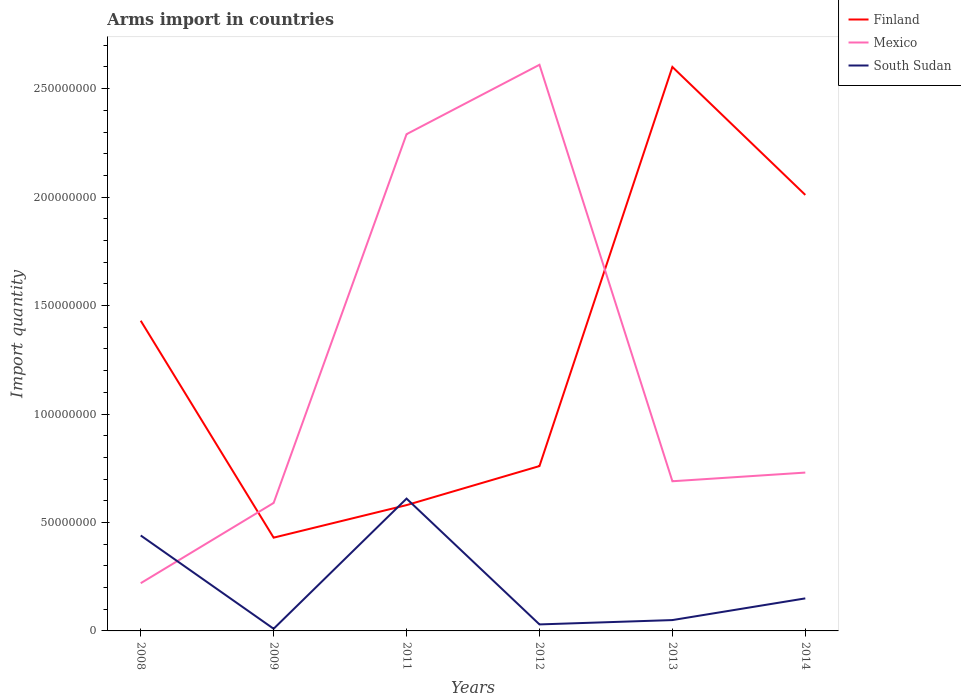Across all years, what is the maximum total arms import in South Sudan?
Your answer should be very brief. 1.00e+06. In which year was the total arms import in Mexico maximum?
Your answer should be compact. 2008. What is the total total arms import in South Sudan in the graph?
Give a very brief answer. -1.70e+07. What is the difference between the highest and the second highest total arms import in Mexico?
Provide a succinct answer. 2.39e+08. What is the difference between the highest and the lowest total arms import in Mexico?
Your answer should be very brief. 2. What is the difference between two consecutive major ticks on the Y-axis?
Ensure brevity in your answer.  5.00e+07. Are the values on the major ticks of Y-axis written in scientific E-notation?
Keep it short and to the point. No. Does the graph contain any zero values?
Give a very brief answer. No. Does the graph contain grids?
Give a very brief answer. No. What is the title of the graph?
Provide a succinct answer. Arms import in countries. Does "Latvia" appear as one of the legend labels in the graph?
Offer a terse response. No. What is the label or title of the X-axis?
Provide a short and direct response. Years. What is the label or title of the Y-axis?
Your answer should be very brief. Import quantity. What is the Import quantity of Finland in 2008?
Ensure brevity in your answer.  1.43e+08. What is the Import quantity of Mexico in 2008?
Ensure brevity in your answer.  2.20e+07. What is the Import quantity in South Sudan in 2008?
Your answer should be very brief. 4.40e+07. What is the Import quantity of Finland in 2009?
Ensure brevity in your answer.  4.30e+07. What is the Import quantity in Mexico in 2009?
Your answer should be very brief. 5.90e+07. What is the Import quantity in Finland in 2011?
Your answer should be compact. 5.80e+07. What is the Import quantity of Mexico in 2011?
Ensure brevity in your answer.  2.29e+08. What is the Import quantity of South Sudan in 2011?
Provide a succinct answer. 6.10e+07. What is the Import quantity in Finland in 2012?
Your answer should be compact. 7.60e+07. What is the Import quantity in Mexico in 2012?
Give a very brief answer. 2.61e+08. What is the Import quantity of Finland in 2013?
Your answer should be very brief. 2.60e+08. What is the Import quantity of Mexico in 2013?
Provide a succinct answer. 6.90e+07. What is the Import quantity of South Sudan in 2013?
Offer a terse response. 5.00e+06. What is the Import quantity in Finland in 2014?
Offer a terse response. 2.01e+08. What is the Import quantity of Mexico in 2014?
Provide a succinct answer. 7.30e+07. What is the Import quantity of South Sudan in 2014?
Provide a short and direct response. 1.50e+07. Across all years, what is the maximum Import quantity in Finland?
Offer a very short reply. 2.60e+08. Across all years, what is the maximum Import quantity of Mexico?
Make the answer very short. 2.61e+08. Across all years, what is the maximum Import quantity of South Sudan?
Your response must be concise. 6.10e+07. Across all years, what is the minimum Import quantity of Finland?
Offer a terse response. 4.30e+07. Across all years, what is the minimum Import quantity of Mexico?
Make the answer very short. 2.20e+07. What is the total Import quantity of Finland in the graph?
Your response must be concise. 7.81e+08. What is the total Import quantity in Mexico in the graph?
Make the answer very short. 7.13e+08. What is the total Import quantity of South Sudan in the graph?
Your response must be concise. 1.29e+08. What is the difference between the Import quantity of Mexico in 2008 and that in 2009?
Provide a short and direct response. -3.70e+07. What is the difference between the Import quantity in South Sudan in 2008 and that in 2009?
Your answer should be very brief. 4.30e+07. What is the difference between the Import quantity in Finland in 2008 and that in 2011?
Offer a terse response. 8.50e+07. What is the difference between the Import quantity of Mexico in 2008 and that in 2011?
Keep it short and to the point. -2.07e+08. What is the difference between the Import quantity of South Sudan in 2008 and that in 2011?
Provide a short and direct response. -1.70e+07. What is the difference between the Import quantity of Finland in 2008 and that in 2012?
Your answer should be very brief. 6.70e+07. What is the difference between the Import quantity of Mexico in 2008 and that in 2012?
Give a very brief answer. -2.39e+08. What is the difference between the Import quantity of South Sudan in 2008 and that in 2012?
Your response must be concise. 4.10e+07. What is the difference between the Import quantity of Finland in 2008 and that in 2013?
Provide a short and direct response. -1.17e+08. What is the difference between the Import quantity in Mexico in 2008 and that in 2013?
Your answer should be very brief. -4.70e+07. What is the difference between the Import quantity in South Sudan in 2008 and that in 2013?
Offer a terse response. 3.90e+07. What is the difference between the Import quantity in Finland in 2008 and that in 2014?
Provide a succinct answer. -5.80e+07. What is the difference between the Import quantity in Mexico in 2008 and that in 2014?
Give a very brief answer. -5.10e+07. What is the difference between the Import quantity of South Sudan in 2008 and that in 2014?
Your answer should be very brief. 2.90e+07. What is the difference between the Import quantity in Finland in 2009 and that in 2011?
Your answer should be very brief. -1.50e+07. What is the difference between the Import quantity of Mexico in 2009 and that in 2011?
Provide a short and direct response. -1.70e+08. What is the difference between the Import quantity of South Sudan in 2009 and that in 2011?
Offer a terse response. -6.00e+07. What is the difference between the Import quantity of Finland in 2009 and that in 2012?
Keep it short and to the point. -3.30e+07. What is the difference between the Import quantity of Mexico in 2009 and that in 2012?
Provide a short and direct response. -2.02e+08. What is the difference between the Import quantity of Finland in 2009 and that in 2013?
Your answer should be very brief. -2.17e+08. What is the difference between the Import quantity of Mexico in 2009 and that in 2013?
Your answer should be very brief. -1.00e+07. What is the difference between the Import quantity of Finland in 2009 and that in 2014?
Provide a succinct answer. -1.58e+08. What is the difference between the Import quantity in Mexico in 2009 and that in 2014?
Ensure brevity in your answer.  -1.40e+07. What is the difference between the Import quantity in South Sudan in 2009 and that in 2014?
Ensure brevity in your answer.  -1.40e+07. What is the difference between the Import quantity in Finland in 2011 and that in 2012?
Your response must be concise. -1.80e+07. What is the difference between the Import quantity of Mexico in 2011 and that in 2012?
Give a very brief answer. -3.20e+07. What is the difference between the Import quantity of South Sudan in 2011 and that in 2012?
Make the answer very short. 5.80e+07. What is the difference between the Import quantity in Finland in 2011 and that in 2013?
Your answer should be very brief. -2.02e+08. What is the difference between the Import quantity of Mexico in 2011 and that in 2013?
Give a very brief answer. 1.60e+08. What is the difference between the Import quantity in South Sudan in 2011 and that in 2013?
Your response must be concise. 5.60e+07. What is the difference between the Import quantity of Finland in 2011 and that in 2014?
Your response must be concise. -1.43e+08. What is the difference between the Import quantity in Mexico in 2011 and that in 2014?
Provide a short and direct response. 1.56e+08. What is the difference between the Import quantity in South Sudan in 2011 and that in 2014?
Your response must be concise. 4.60e+07. What is the difference between the Import quantity in Finland in 2012 and that in 2013?
Give a very brief answer. -1.84e+08. What is the difference between the Import quantity in Mexico in 2012 and that in 2013?
Provide a succinct answer. 1.92e+08. What is the difference between the Import quantity in Finland in 2012 and that in 2014?
Give a very brief answer. -1.25e+08. What is the difference between the Import quantity of Mexico in 2012 and that in 2014?
Offer a very short reply. 1.88e+08. What is the difference between the Import quantity in South Sudan in 2012 and that in 2014?
Ensure brevity in your answer.  -1.20e+07. What is the difference between the Import quantity in Finland in 2013 and that in 2014?
Keep it short and to the point. 5.90e+07. What is the difference between the Import quantity of Mexico in 2013 and that in 2014?
Keep it short and to the point. -4.00e+06. What is the difference between the Import quantity in South Sudan in 2013 and that in 2014?
Provide a short and direct response. -1.00e+07. What is the difference between the Import quantity in Finland in 2008 and the Import quantity in Mexico in 2009?
Your response must be concise. 8.40e+07. What is the difference between the Import quantity of Finland in 2008 and the Import quantity of South Sudan in 2009?
Provide a succinct answer. 1.42e+08. What is the difference between the Import quantity in Mexico in 2008 and the Import quantity in South Sudan in 2009?
Your response must be concise. 2.10e+07. What is the difference between the Import quantity of Finland in 2008 and the Import quantity of Mexico in 2011?
Ensure brevity in your answer.  -8.60e+07. What is the difference between the Import quantity in Finland in 2008 and the Import quantity in South Sudan in 2011?
Offer a terse response. 8.20e+07. What is the difference between the Import quantity in Mexico in 2008 and the Import quantity in South Sudan in 2011?
Keep it short and to the point. -3.90e+07. What is the difference between the Import quantity in Finland in 2008 and the Import quantity in Mexico in 2012?
Give a very brief answer. -1.18e+08. What is the difference between the Import quantity of Finland in 2008 and the Import quantity of South Sudan in 2012?
Give a very brief answer. 1.40e+08. What is the difference between the Import quantity in Mexico in 2008 and the Import quantity in South Sudan in 2012?
Your answer should be compact. 1.90e+07. What is the difference between the Import quantity of Finland in 2008 and the Import quantity of Mexico in 2013?
Offer a terse response. 7.40e+07. What is the difference between the Import quantity in Finland in 2008 and the Import quantity in South Sudan in 2013?
Keep it short and to the point. 1.38e+08. What is the difference between the Import quantity in Mexico in 2008 and the Import quantity in South Sudan in 2013?
Ensure brevity in your answer.  1.70e+07. What is the difference between the Import quantity of Finland in 2008 and the Import quantity of Mexico in 2014?
Provide a succinct answer. 7.00e+07. What is the difference between the Import quantity in Finland in 2008 and the Import quantity in South Sudan in 2014?
Provide a short and direct response. 1.28e+08. What is the difference between the Import quantity in Mexico in 2008 and the Import quantity in South Sudan in 2014?
Your answer should be compact. 7.00e+06. What is the difference between the Import quantity of Finland in 2009 and the Import quantity of Mexico in 2011?
Provide a succinct answer. -1.86e+08. What is the difference between the Import quantity in Finland in 2009 and the Import quantity in South Sudan in 2011?
Give a very brief answer. -1.80e+07. What is the difference between the Import quantity of Mexico in 2009 and the Import quantity of South Sudan in 2011?
Your answer should be compact. -2.00e+06. What is the difference between the Import quantity of Finland in 2009 and the Import quantity of Mexico in 2012?
Offer a very short reply. -2.18e+08. What is the difference between the Import quantity in Finland in 2009 and the Import quantity in South Sudan in 2012?
Make the answer very short. 4.00e+07. What is the difference between the Import quantity in Mexico in 2009 and the Import quantity in South Sudan in 2012?
Your answer should be compact. 5.60e+07. What is the difference between the Import quantity of Finland in 2009 and the Import quantity of Mexico in 2013?
Your answer should be very brief. -2.60e+07. What is the difference between the Import quantity in Finland in 2009 and the Import quantity in South Sudan in 2013?
Your answer should be compact. 3.80e+07. What is the difference between the Import quantity in Mexico in 2009 and the Import quantity in South Sudan in 2013?
Offer a terse response. 5.40e+07. What is the difference between the Import quantity in Finland in 2009 and the Import quantity in Mexico in 2014?
Provide a short and direct response. -3.00e+07. What is the difference between the Import quantity in Finland in 2009 and the Import quantity in South Sudan in 2014?
Provide a short and direct response. 2.80e+07. What is the difference between the Import quantity of Mexico in 2009 and the Import quantity of South Sudan in 2014?
Your answer should be very brief. 4.40e+07. What is the difference between the Import quantity of Finland in 2011 and the Import quantity of Mexico in 2012?
Give a very brief answer. -2.03e+08. What is the difference between the Import quantity of Finland in 2011 and the Import quantity of South Sudan in 2012?
Provide a succinct answer. 5.50e+07. What is the difference between the Import quantity in Mexico in 2011 and the Import quantity in South Sudan in 2012?
Provide a short and direct response. 2.26e+08. What is the difference between the Import quantity of Finland in 2011 and the Import quantity of Mexico in 2013?
Your answer should be compact. -1.10e+07. What is the difference between the Import quantity of Finland in 2011 and the Import quantity of South Sudan in 2013?
Your response must be concise. 5.30e+07. What is the difference between the Import quantity in Mexico in 2011 and the Import quantity in South Sudan in 2013?
Make the answer very short. 2.24e+08. What is the difference between the Import quantity of Finland in 2011 and the Import quantity of Mexico in 2014?
Offer a terse response. -1.50e+07. What is the difference between the Import quantity of Finland in 2011 and the Import quantity of South Sudan in 2014?
Your response must be concise. 4.30e+07. What is the difference between the Import quantity in Mexico in 2011 and the Import quantity in South Sudan in 2014?
Make the answer very short. 2.14e+08. What is the difference between the Import quantity in Finland in 2012 and the Import quantity in South Sudan in 2013?
Offer a very short reply. 7.10e+07. What is the difference between the Import quantity of Mexico in 2012 and the Import quantity of South Sudan in 2013?
Make the answer very short. 2.56e+08. What is the difference between the Import quantity of Finland in 2012 and the Import quantity of South Sudan in 2014?
Your response must be concise. 6.10e+07. What is the difference between the Import quantity of Mexico in 2012 and the Import quantity of South Sudan in 2014?
Provide a succinct answer. 2.46e+08. What is the difference between the Import quantity in Finland in 2013 and the Import quantity in Mexico in 2014?
Offer a terse response. 1.87e+08. What is the difference between the Import quantity in Finland in 2013 and the Import quantity in South Sudan in 2014?
Your answer should be compact. 2.45e+08. What is the difference between the Import quantity of Mexico in 2013 and the Import quantity of South Sudan in 2014?
Offer a terse response. 5.40e+07. What is the average Import quantity in Finland per year?
Your answer should be compact. 1.30e+08. What is the average Import quantity of Mexico per year?
Ensure brevity in your answer.  1.19e+08. What is the average Import quantity of South Sudan per year?
Offer a terse response. 2.15e+07. In the year 2008, what is the difference between the Import quantity in Finland and Import quantity in Mexico?
Offer a terse response. 1.21e+08. In the year 2008, what is the difference between the Import quantity in Finland and Import quantity in South Sudan?
Provide a succinct answer. 9.90e+07. In the year 2008, what is the difference between the Import quantity of Mexico and Import quantity of South Sudan?
Give a very brief answer. -2.20e+07. In the year 2009, what is the difference between the Import quantity in Finland and Import quantity in Mexico?
Provide a short and direct response. -1.60e+07. In the year 2009, what is the difference between the Import quantity in Finland and Import quantity in South Sudan?
Give a very brief answer. 4.20e+07. In the year 2009, what is the difference between the Import quantity of Mexico and Import quantity of South Sudan?
Your answer should be very brief. 5.80e+07. In the year 2011, what is the difference between the Import quantity of Finland and Import quantity of Mexico?
Provide a succinct answer. -1.71e+08. In the year 2011, what is the difference between the Import quantity of Mexico and Import quantity of South Sudan?
Give a very brief answer. 1.68e+08. In the year 2012, what is the difference between the Import quantity of Finland and Import quantity of Mexico?
Give a very brief answer. -1.85e+08. In the year 2012, what is the difference between the Import quantity of Finland and Import quantity of South Sudan?
Your answer should be very brief. 7.30e+07. In the year 2012, what is the difference between the Import quantity in Mexico and Import quantity in South Sudan?
Your answer should be very brief. 2.58e+08. In the year 2013, what is the difference between the Import quantity in Finland and Import quantity in Mexico?
Your response must be concise. 1.91e+08. In the year 2013, what is the difference between the Import quantity of Finland and Import quantity of South Sudan?
Provide a short and direct response. 2.55e+08. In the year 2013, what is the difference between the Import quantity of Mexico and Import quantity of South Sudan?
Offer a very short reply. 6.40e+07. In the year 2014, what is the difference between the Import quantity in Finland and Import quantity in Mexico?
Provide a short and direct response. 1.28e+08. In the year 2014, what is the difference between the Import quantity of Finland and Import quantity of South Sudan?
Give a very brief answer. 1.86e+08. In the year 2014, what is the difference between the Import quantity of Mexico and Import quantity of South Sudan?
Offer a very short reply. 5.80e+07. What is the ratio of the Import quantity in Finland in 2008 to that in 2009?
Your answer should be very brief. 3.33. What is the ratio of the Import quantity in Mexico in 2008 to that in 2009?
Offer a very short reply. 0.37. What is the ratio of the Import quantity of South Sudan in 2008 to that in 2009?
Make the answer very short. 44. What is the ratio of the Import quantity of Finland in 2008 to that in 2011?
Make the answer very short. 2.47. What is the ratio of the Import quantity of Mexico in 2008 to that in 2011?
Keep it short and to the point. 0.1. What is the ratio of the Import quantity in South Sudan in 2008 to that in 2011?
Your answer should be compact. 0.72. What is the ratio of the Import quantity in Finland in 2008 to that in 2012?
Provide a succinct answer. 1.88. What is the ratio of the Import quantity in Mexico in 2008 to that in 2012?
Provide a short and direct response. 0.08. What is the ratio of the Import quantity of South Sudan in 2008 to that in 2012?
Provide a succinct answer. 14.67. What is the ratio of the Import quantity of Finland in 2008 to that in 2013?
Your answer should be compact. 0.55. What is the ratio of the Import quantity in Mexico in 2008 to that in 2013?
Give a very brief answer. 0.32. What is the ratio of the Import quantity in South Sudan in 2008 to that in 2013?
Your response must be concise. 8.8. What is the ratio of the Import quantity in Finland in 2008 to that in 2014?
Make the answer very short. 0.71. What is the ratio of the Import quantity in Mexico in 2008 to that in 2014?
Offer a very short reply. 0.3. What is the ratio of the Import quantity in South Sudan in 2008 to that in 2014?
Give a very brief answer. 2.93. What is the ratio of the Import quantity in Finland in 2009 to that in 2011?
Give a very brief answer. 0.74. What is the ratio of the Import quantity of Mexico in 2009 to that in 2011?
Make the answer very short. 0.26. What is the ratio of the Import quantity in South Sudan in 2009 to that in 2011?
Your response must be concise. 0.02. What is the ratio of the Import quantity of Finland in 2009 to that in 2012?
Make the answer very short. 0.57. What is the ratio of the Import quantity of Mexico in 2009 to that in 2012?
Offer a very short reply. 0.23. What is the ratio of the Import quantity of South Sudan in 2009 to that in 2012?
Your answer should be very brief. 0.33. What is the ratio of the Import quantity in Finland in 2009 to that in 2013?
Your answer should be compact. 0.17. What is the ratio of the Import quantity in Mexico in 2009 to that in 2013?
Your answer should be compact. 0.86. What is the ratio of the Import quantity of Finland in 2009 to that in 2014?
Provide a short and direct response. 0.21. What is the ratio of the Import quantity of Mexico in 2009 to that in 2014?
Your answer should be very brief. 0.81. What is the ratio of the Import quantity of South Sudan in 2009 to that in 2014?
Keep it short and to the point. 0.07. What is the ratio of the Import quantity in Finland in 2011 to that in 2012?
Your answer should be very brief. 0.76. What is the ratio of the Import quantity of Mexico in 2011 to that in 2012?
Ensure brevity in your answer.  0.88. What is the ratio of the Import quantity in South Sudan in 2011 to that in 2012?
Give a very brief answer. 20.33. What is the ratio of the Import quantity of Finland in 2011 to that in 2013?
Your answer should be compact. 0.22. What is the ratio of the Import quantity of Mexico in 2011 to that in 2013?
Your answer should be compact. 3.32. What is the ratio of the Import quantity in South Sudan in 2011 to that in 2013?
Keep it short and to the point. 12.2. What is the ratio of the Import quantity in Finland in 2011 to that in 2014?
Keep it short and to the point. 0.29. What is the ratio of the Import quantity in Mexico in 2011 to that in 2014?
Provide a short and direct response. 3.14. What is the ratio of the Import quantity in South Sudan in 2011 to that in 2014?
Your answer should be compact. 4.07. What is the ratio of the Import quantity of Finland in 2012 to that in 2013?
Offer a very short reply. 0.29. What is the ratio of the Import quantity of Mexico in 2012 to that in 2013?
Offer a very short reply. 3.78. What is the ratio of the Import quantity of South Sudan in 2012 to that in 2013?
Provide a succinct answer. 0.6. What is the ratio of the Import quantity in Finland in 2012 to that in 2014?
Your answer should be compact. 0.38. What is the ratio of the Import quantity in Mexico in 2012 to that in 2014?
Keep it short and to the point. 3.58. What is the ratio of the Import quantity of Finland in 2013 to that in 2014?
Your answer should be compact. 1.29. What is the ratio of the Import quantity of Mexico in 2013 to that in 2014?
Make the answer very short. 0.95. What is the difference between the highest and the second highest Import quantity of Finland?
Give a very brief answer. 5.90e+07. What is the difference between the highest and the second highest Import quantity of Mexico?
Ensure brevity in your answer.  3.20e+07. What is the difference between the highest and the second highest Import quantity of South Sudan?
Offer a terse response. 1.70e+07. What is the difference between the highest and the lowest Import quantity of Finland?
Provide a short and direct response. 2.17e+08. What is the difference between the highest and the lowest Import quantity in Mexico?
Make the answer very short. 2.39e+08. What is the difference between the highest and the lowest Import quantity of South Sudan?
Keep it short and to the point. 6.00e+07. 